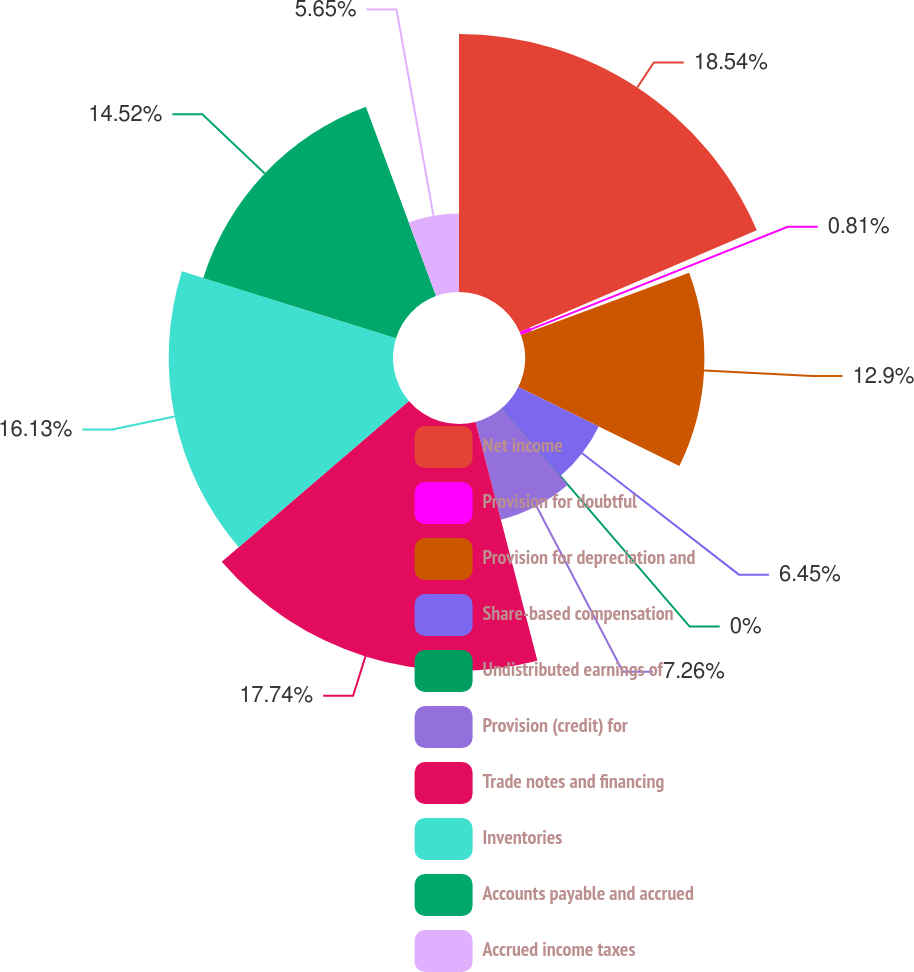<chart> <loc_0><loc_0><loc_500><loc_500><pie_chart><fcel>Net income<fcel>Provision for doubtful<fcel>Provision for depreciation and<fcel>Share-based compensation<fcel>Undistributed earnings of<fcel>Provision (credit) for<fcel>Trade notes and financing<fcel>Inventories<fcel>Accounts payable and accrued<fcel>Accrued income taxes<nl><fcel>18.55%<fcel>0.81%<fcel>12.9%<fcel>6.45%<fcel>0.0%<fcel>7.26%<fcel>17.74%<fcel>16.13%<fcel>14.52%<fcel>5.65%<nl></chart> 